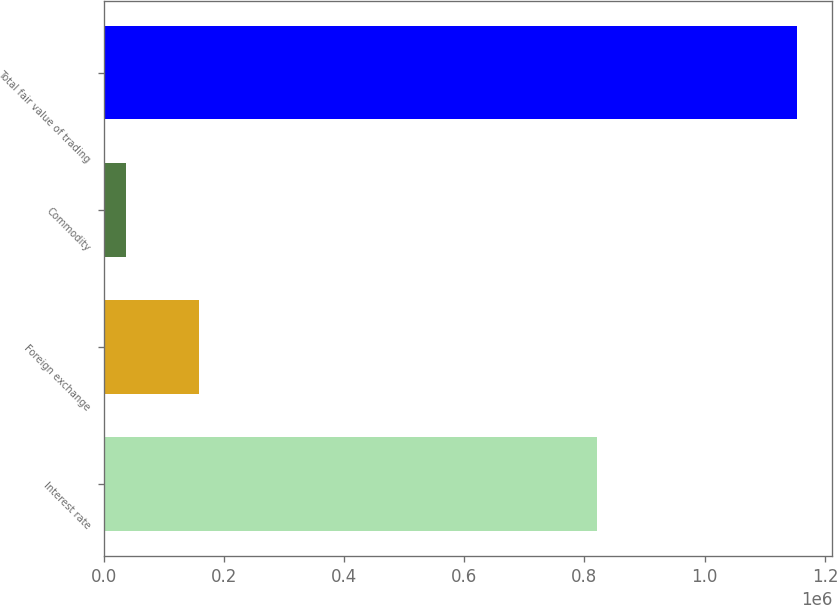Convert chart to OTSL. <chart><loc_0><loc_0><loc_500><loc_500><bar_chart><fcel>Interest rate<fcel>Foreign exchange<fcel>Commodity<fcel>Total fair value of trading<nl><fcel>820811<fcel>158728<fcel>37605<fcel>1.1542e+06<nl></chart> 